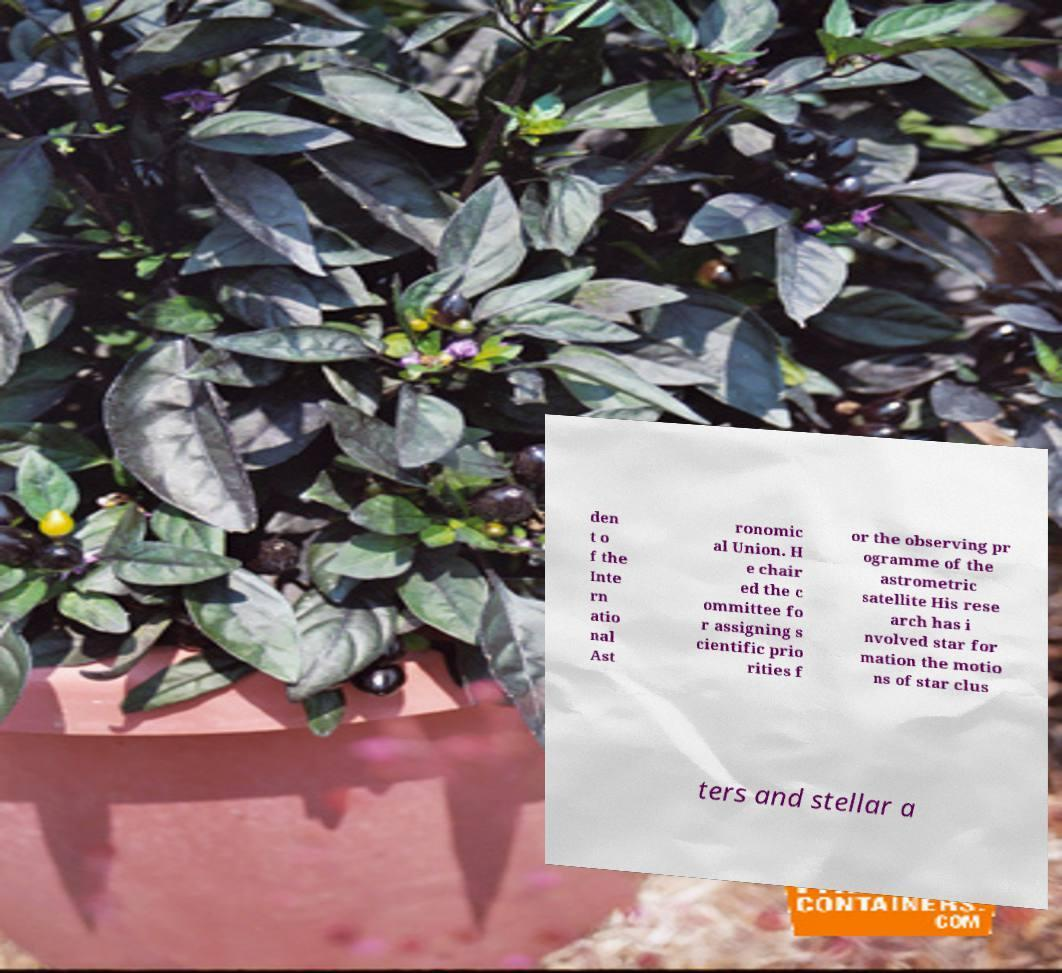What messages or text are displayed in this image? I need them in a readable, typed format. den t o f the Inte rn atio nal Ast ronomic al Union. H e chair ed the c ommittee fo r assigning s cientific prio rities f or the observing pr ogramme of the astrometric satellite His rese arch has i nvolved star for mation the motio ns of star clus ters and stellar a 